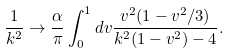<formula> <loc_0><loc_0><loc_500><loc_500>\frac { 1 } { k ^ { 2 } } \rightarrow \frac { \alpha } { \pi } \int _ { 0 } ^ { 1 } d v \frac { v ^ { 2 } ( 1 - v ^ { 2 } / 3 ) } { k ^ { 2 } ( 1 - v ^ { 2 } ) - 4 } .</formula> 